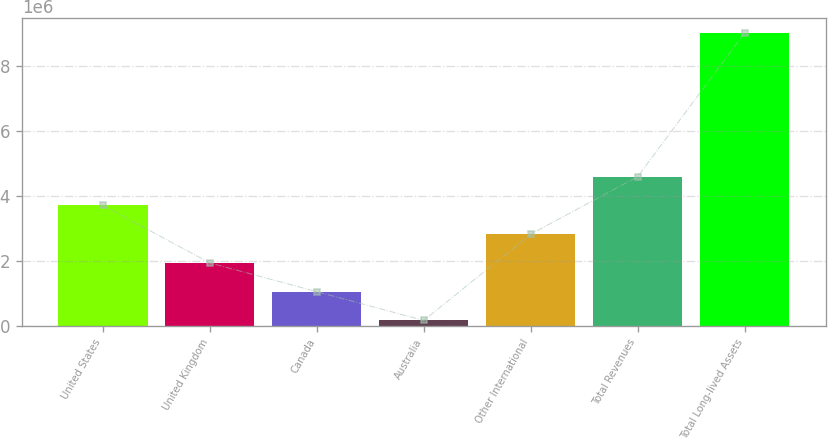Convert chart to OTSL. <chart><loc_0><loc_0><loc_500><loc_500><bar_chart><fcel>United States<fcel>United Kingdom<fcel>Canada<fcel>Australia<fcel>Other International<fcel>Total Revenues<fcel>Total Long-lived Assets<nl><fcel>3.70323e+06<fcel>1.93028e+06<fcel>1.04381e+06<fcel>157333<fcel>2.81676e+06<fcel>4.58971e+06<fcel>9.02209e+06<nl></chart> 